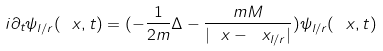Convert formula to latex. <formula><loc_0><loc_0><loc_500><loc_500>i \partial _ { t } \psi _ { l / r } ( \ x , t ) = ( - \frac { 1 } { 2 m } \Delta - \frac { m M } { | \ x - \ x _ { l / r } | } ) \psi _ { l / r } ( \ x , t )</formula> 